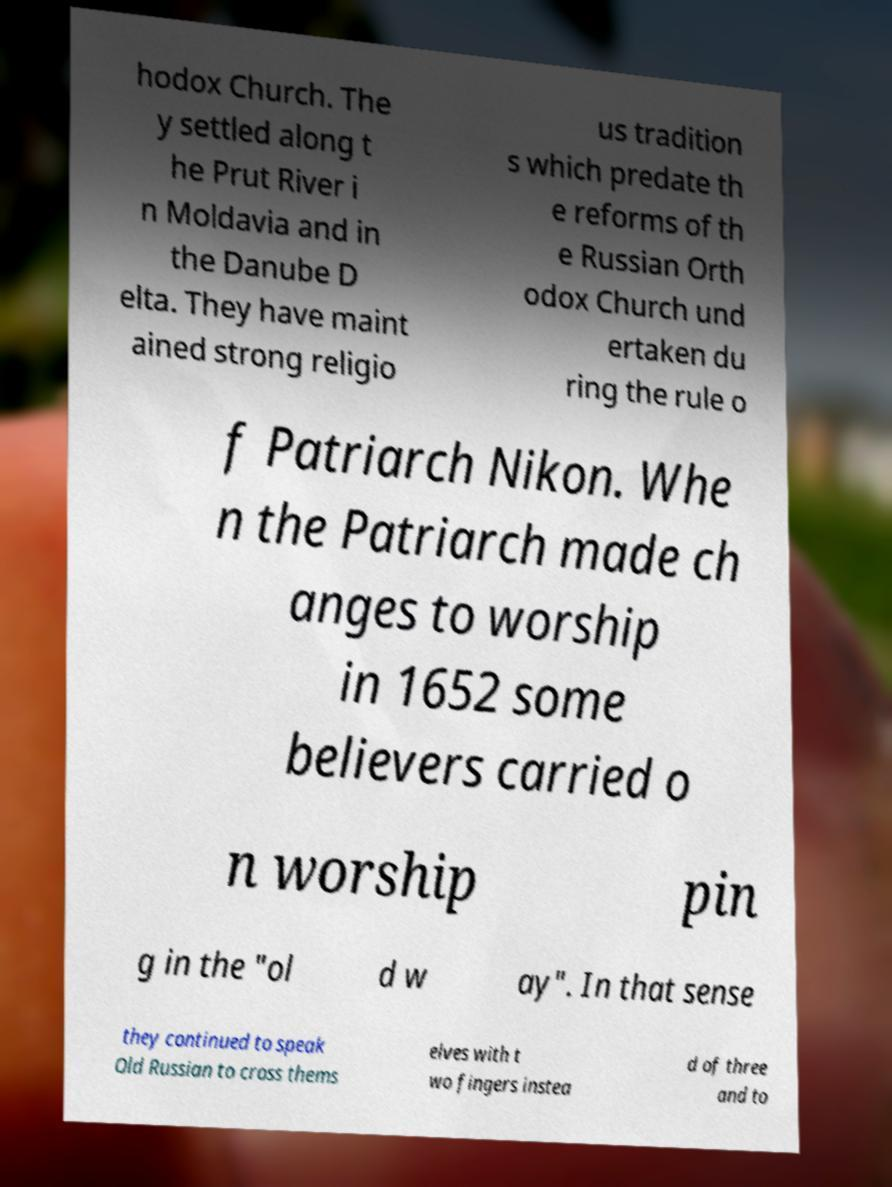Please read and relay the text visible in this image. What does it say? hodox Church. The y settled along t he Prut River i n Moldavia and in the Danube D elta. They have maint ained strong religio us tradition s which predate th e reforms of th e Russian Orth odox Church und ertaken du ring the rule o f Patriarch Nikon. Whe n the Patriarch made ch anges to worship in 1652 some believers carried o n worship pin g in the "ol d w ay". In that sense they continued to speak Old Russian to cross thems elves with t wo fingers instea d of three and to 